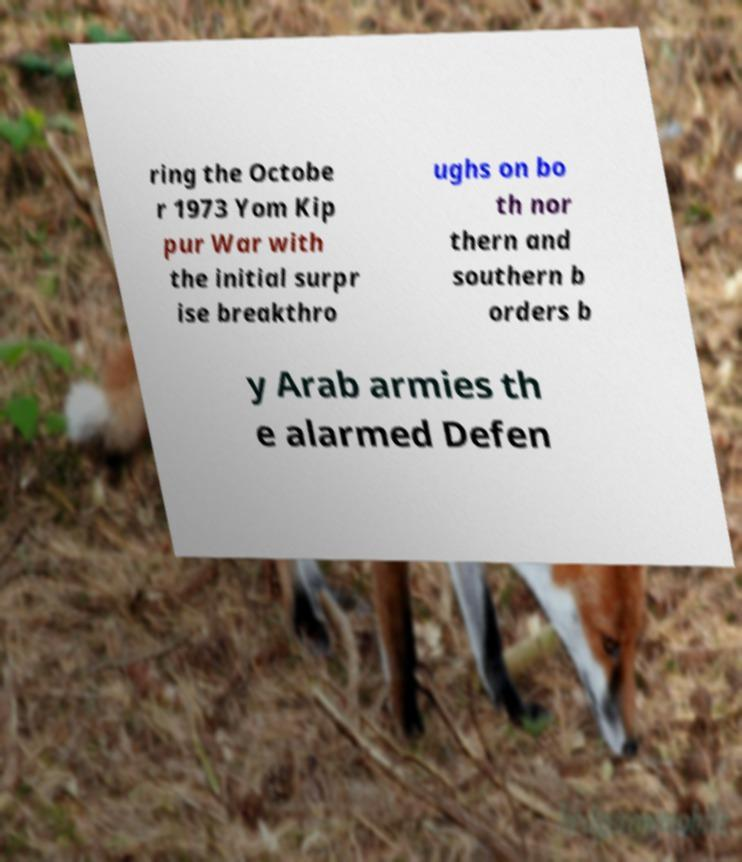Could you extract and type out the text from this image? ring the Octobe r 1973 Yom Kip pur War with the initial surpr ise breakthro ughs on bo th nor thern and southern b orders b y Arab armies th e alarmed Defen 